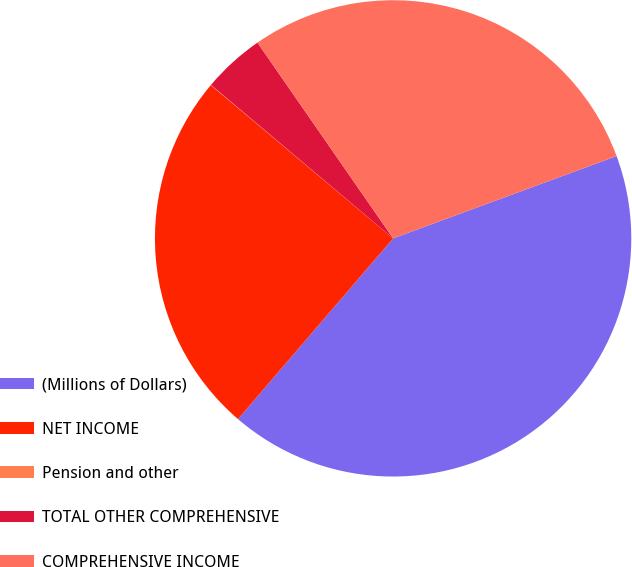Convert chart to OTSL. <chart><loc_0><loc_0><loc_500><loc_500><pie_chart><fcel>(Millions of Dollars)<fcel>NET INCOME<fcel>Pension and other<fcel>TOTAL OTHER COMPREHENSIVE<fcel>COMPREHENSIVE INCOME<nl><fcel>41.91%<fcel>24.84%<fcel>0.02%<fcel>4.21%<fcel>29.03%<nl></chart> 